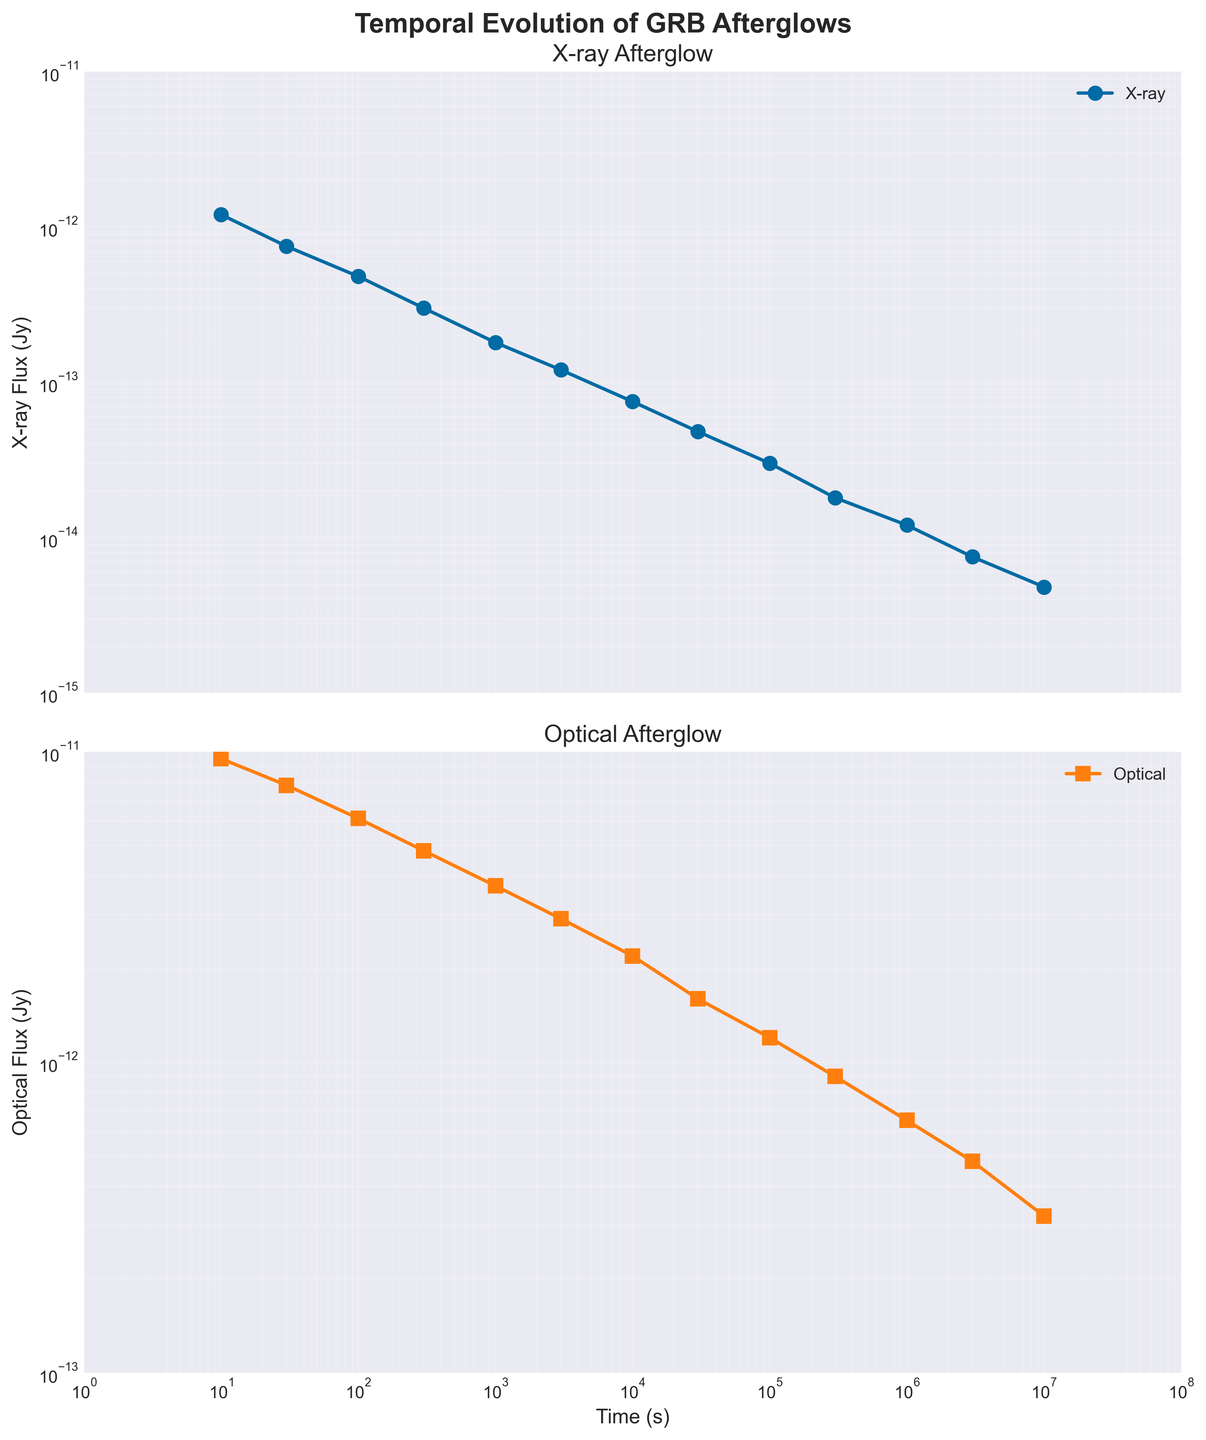What is the title of the figure? The title is found at the top of the figure. It reads "Temporal Evolution of GRB Afterglows."
Answer: Temporal Evolution of GRB Afterglows What type of afterglow has been plotted in the upper subplot? The title of the upper subplot indicates the type of afterglow being plotted, which is specified as "X-ray Afterglow."
Answer: X-ray Afterglow What is the range of the time axis in the plot? The x-axis in both subplots represents time, plotted on a logarithmic scale from 1 second to 10^7 seconds.
Answer: 1 to 10^7 seconds Which afterglow flux shows a steeper decline over time, X-ray or Optical? By observing both plots, the X-ray flux decreases more quickly compared to the Optical flux over the same time period.
Answer: X-ray What are the markers used for X-ray and Optical data points? The X-ray data points use circle markers, and the Optical data points use square markers. This can be inferred from the shapes of the points on the respective subplots.
Answer: X-ray: circles, Optical: squares At what time does the X-ray flux approximate 3.0e-13 Jy? Looking at the X-ray subplot, the flux converges closely to 3.0e-13 Jy around 300 seconds.
Answer: 300 seconds What are the colors used to represent the X-ray and Optical afterglows? The X-ray afterglow subplot uses a blue color, while the Optical afterglow subplot uses an orange color, which is evident from the lines and markers.
Answer: X-ray: blue, Optical: orange What is the X-ray flux at t = 10,000 seconds? From the X-ray subplot, we locate the point at 10,000 seconds on the x-axis and see the corresponding flux value, which is 7.5e-14 Jy.
Answer: 7.5e-14 Jy Between 1,000 seconds and 10,000 seconds, which afterglow flux shows a greater relative decline? Comparing the flux values at 1,000 and 10,000 seconds for each subplot, the X-ray flux drops from 1.8e-13 to 7.5e-14 Jy, whereas the Optical flux decreases from 3.7e-12 to 2.2e-12 Jy. The X-ray flux shows a greater relative decline.
Answer: X-ray What is the lowest flux value for the Optical afterglow in the plot? In the Optical subplot, the lowest flux value can be observed at the far-right end of the curve, which is 3.2e-13 Jy (at around 10,000,000 seconds).
Answer: 3.2e-13 Jy 